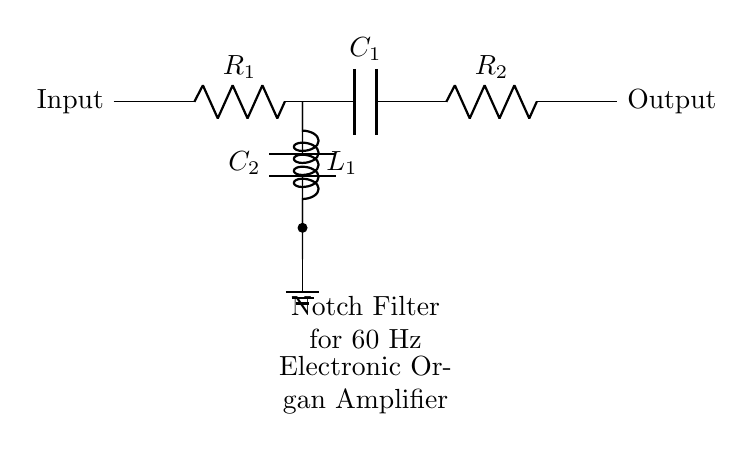What type of filter is represented in the circuit? The circuit diagram depicts a notch filter, which is designed specifically to eliminate unwanted frequencies, such as power line hum. This is evident from the labeling in the diagram.
Answer: notch filter What is the purpose of capacitor C1? Capacitor C1 is part of the main filtering stage, where it works with the resistors to determine the frequency characteristics of the circuit. It also assists in the filtering of high-frequency noise beyond the notch frequency.
Answer: filter What is the impedance of inductor L1 at the notch frequency? The impedance of inductor L1 at the notch frequency is zero. At this frequency, the inductor acts as a short circuit as it allows the specific frequency to bypass the output, which is the essence of a notch filter.
Answer: zero How many resistors are in the circuit? There are two resistors in the circuit, labeled R1 and R2, which contribute to the overall resistance and frequency response of the notch filter.
Answer: two What frequency is the notch filter designed to eliminate? The notch filter is designed to eliminate the frequency of 60 Hz, which corresponds to typical power line interference that can affect electronic amplifiers. This is indicated in the labeling of the circuit.
Answer: 60 Hz What components are used to create the notch filter? The notch filter is created using two resistors (R1 and R2), one inductor (L1), and two capacitors (C1 and C2). These components work together to form the necessary network to attenuate the specific frequency.
Answer: resistors, inductor, capacitors 